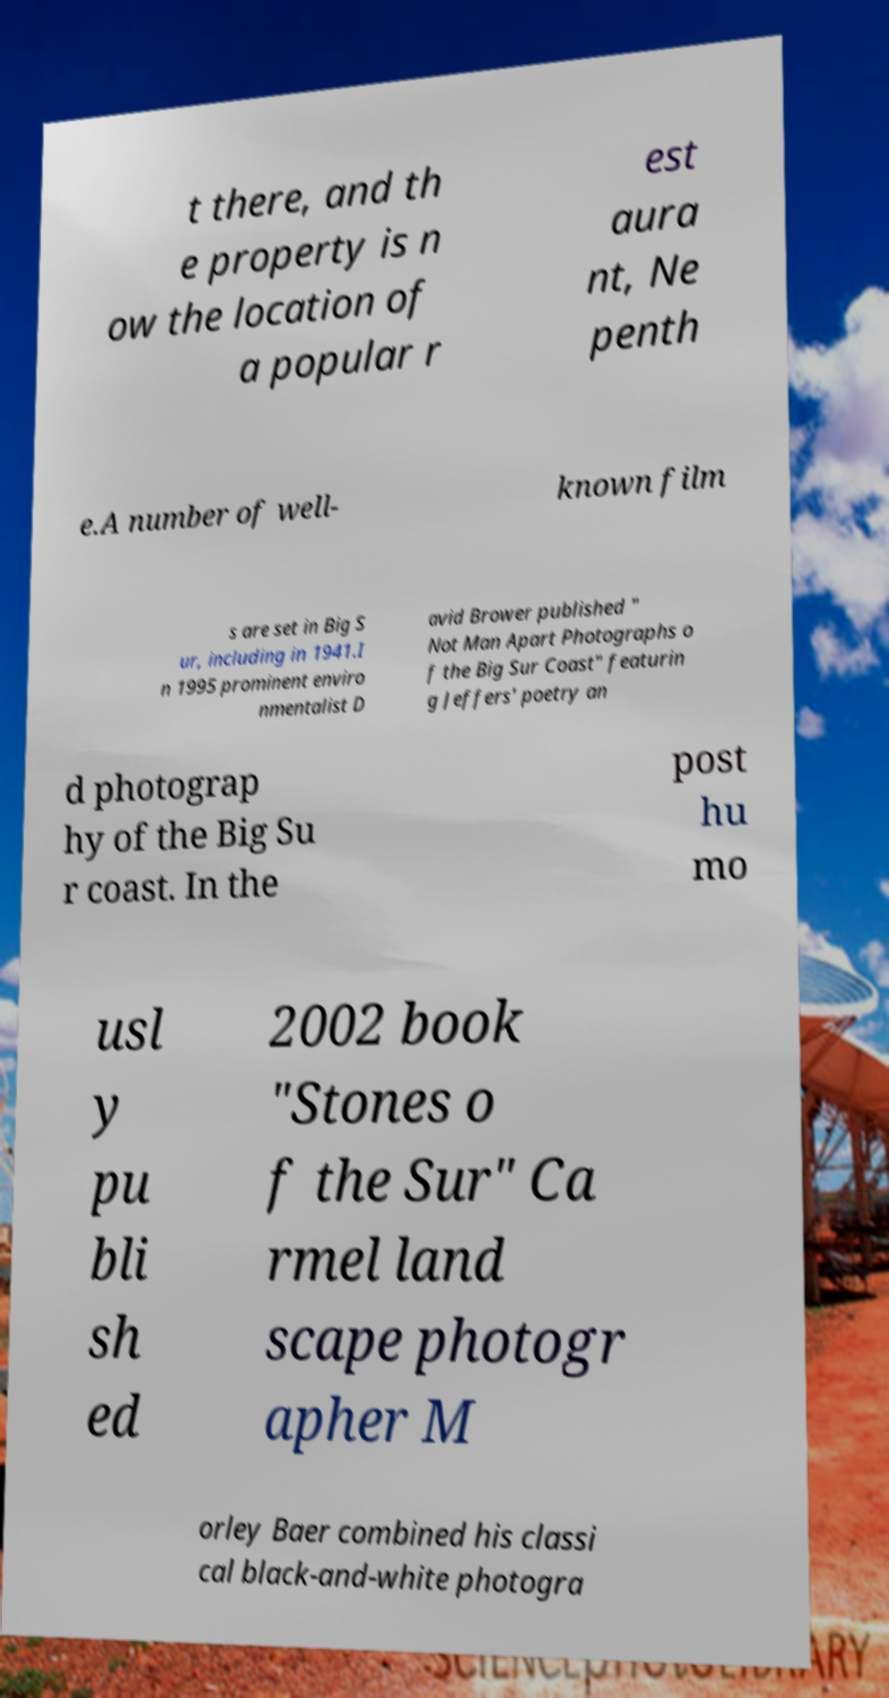What messages or text are displayed in this image? I need them in a readable, typed format. t there, and th e property is n ow the location of a popular r est aura nt, Ne penth e.A number of well- known film s are set in Big S ur, including in 1941.I n 1995 prominent enviro nmentalist D avid Brower published " Not Man Apart Photographs o f the Big Sur Coast" featurin g Jeffers' poetry an d photograp hy of the Big Su r coast. In the post hu mo usl y pu bli sh ed 2002 book "Stones o f the Sur" Ca rmel land scape photogr apher M orley Baer combined his classi cal black-and-white photogra 